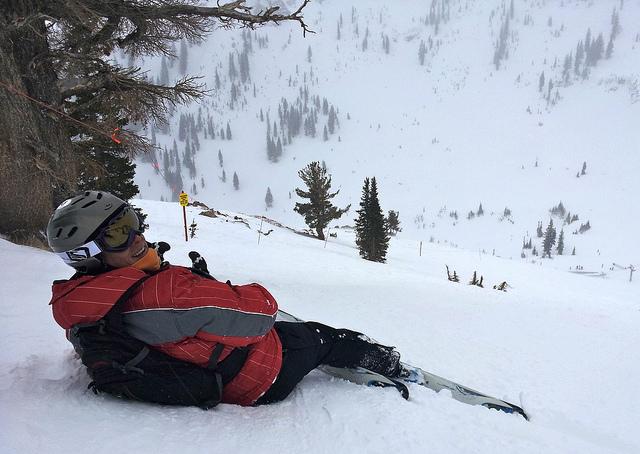What is this man doing?
Answer briefly. Skiing. Is the man ready to ski?
Keep it brief. Yes. Did this man fall?
Answer briefly. Yes. 